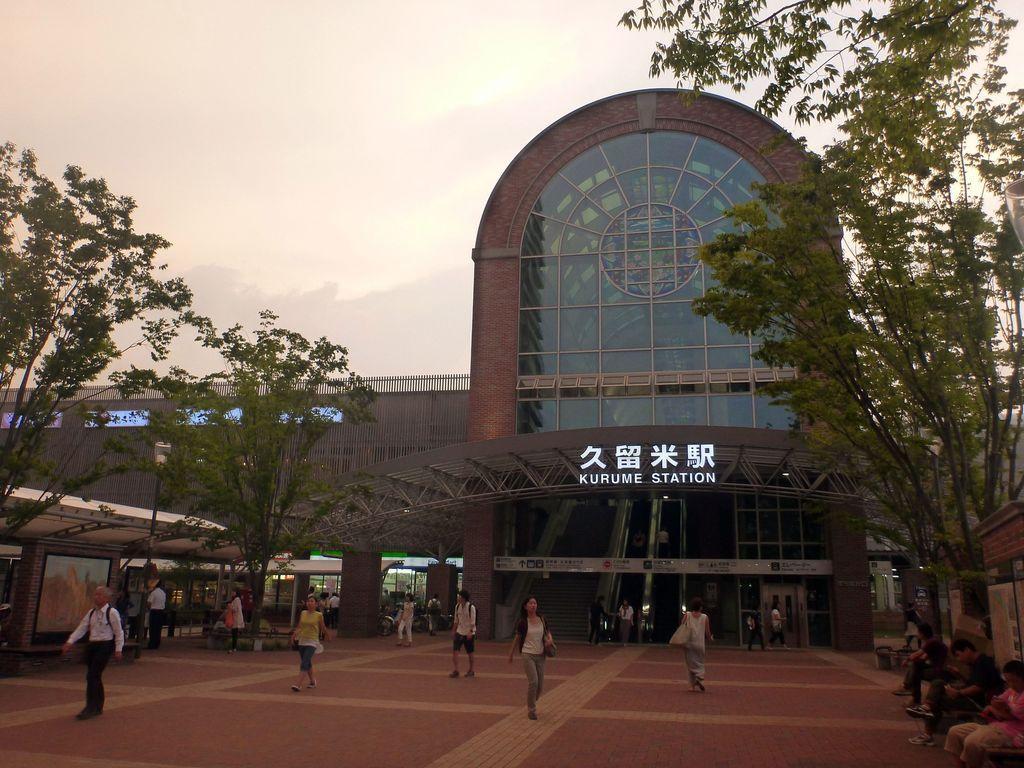Describe this image in one or two sentences. In this image, we can see a building, shed, trees, stairs, walls and few objects. Here we can see few people. Few are walking on the walkway. On the right side of the image, we can see few people are sitting. Background we can see the sky. 